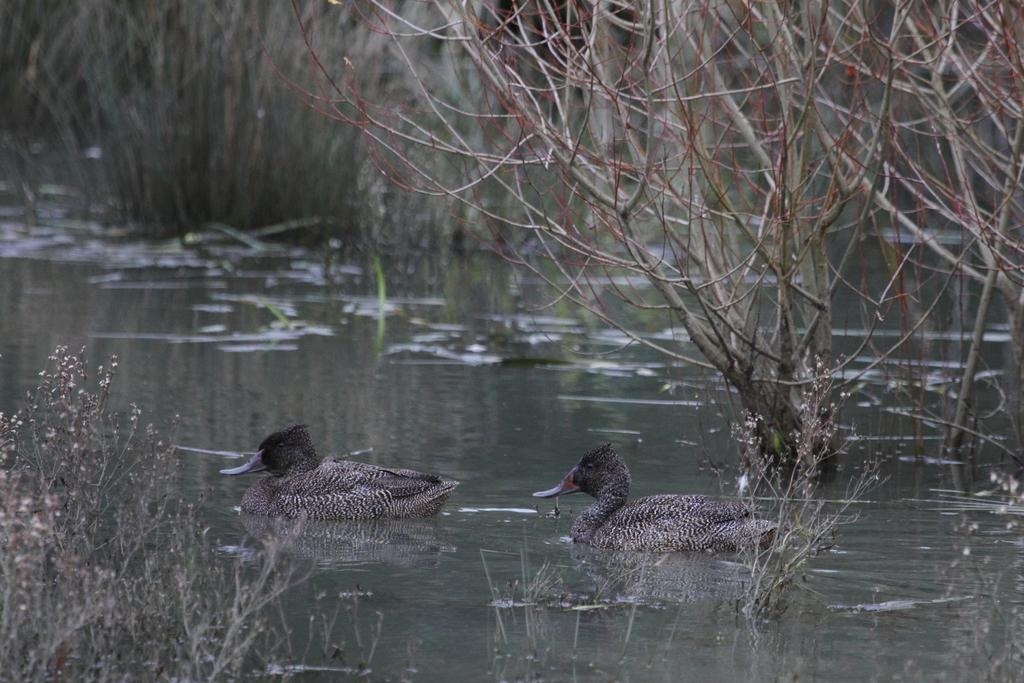What is present in the image that is not solid? There is water visible in the image. What type of living organisms can be seen in the image? There are two ducks in the water. What else can be seen in the water besides the ducks? There are plants in the image. What type of plants are visible in the background of the image? There are water plants in the background of the image. What type of mask is being worn by the duck in the image? There are no masks present in the image, as it features ducks in water with plants. 